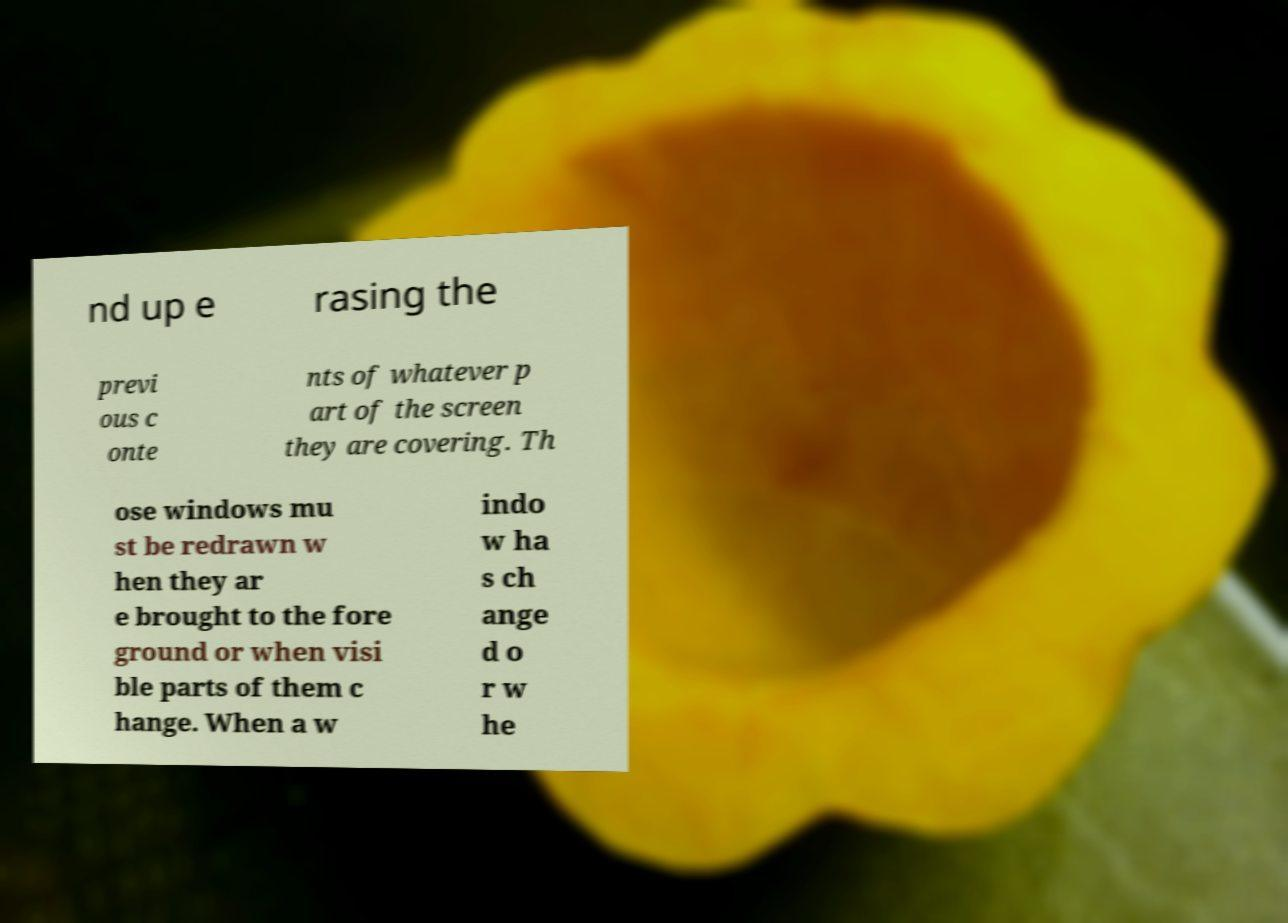What messages or text are displayed in this image? I need them in a readable, typed format. nd up e rasing the previ ous c onte nts of whatever p art of the screen they are covering. Th ose windows mu st be redrawn w hen they ar e brought to the fore ground or when visi ble parts of them c hange. When a w indo w ha s ch ange d o r w he 